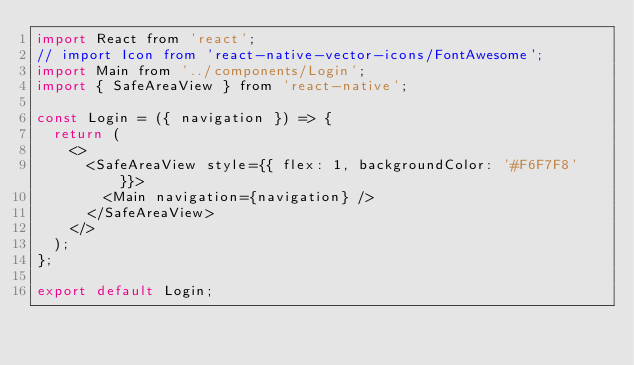<code> <loc_0><loc_0><loc_500><loc_500><_JavaScript_>import React from 'react';
// import Icon from 'react-native-vector-icons/FontAwesome';
import Main from '../components/Login';
import { SafeAreaView } from 'react-native';

const Login = ({ navigation }) => {
  return (
    <>
      <SafeAreaView style={{ flex: 1, backgroundColor: '#F6F7F8' }}>
        <Main navigation={navigation} />
      </SafeAreaView>
    </>
  );
};

export default Login;
</code> 